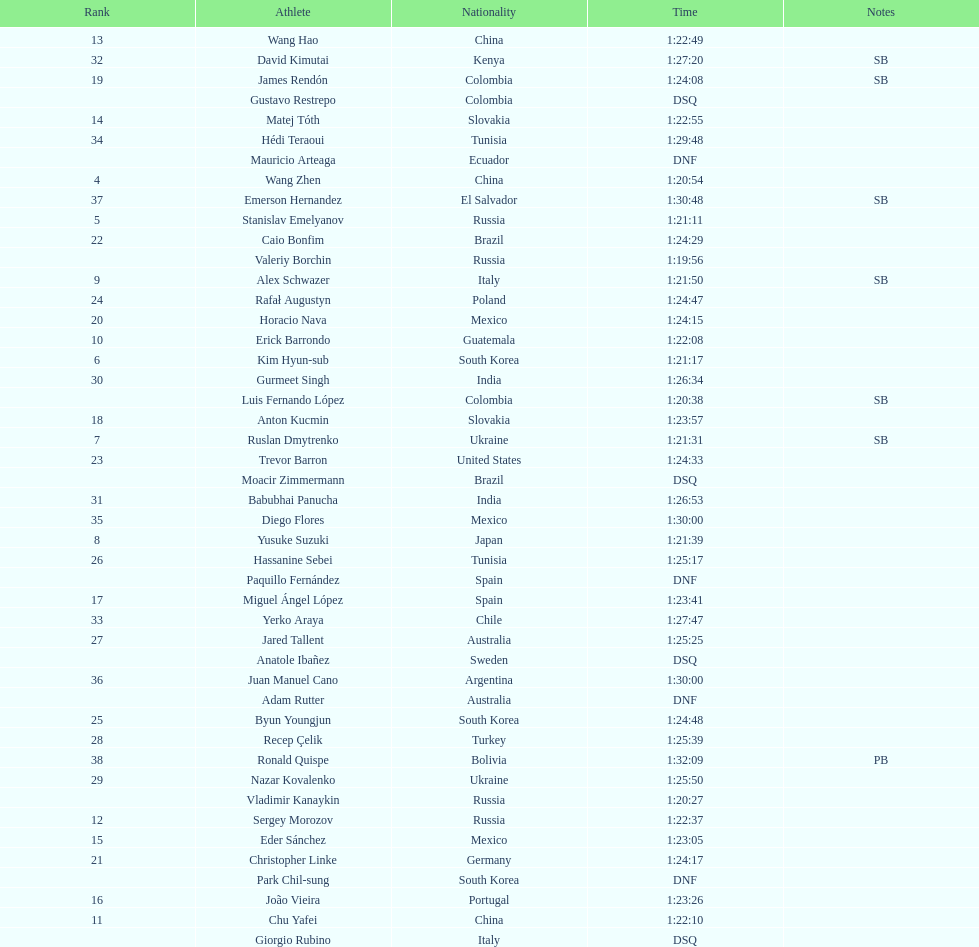Which athlete had the fastest time for the 20km? Valeriy Borchin. 